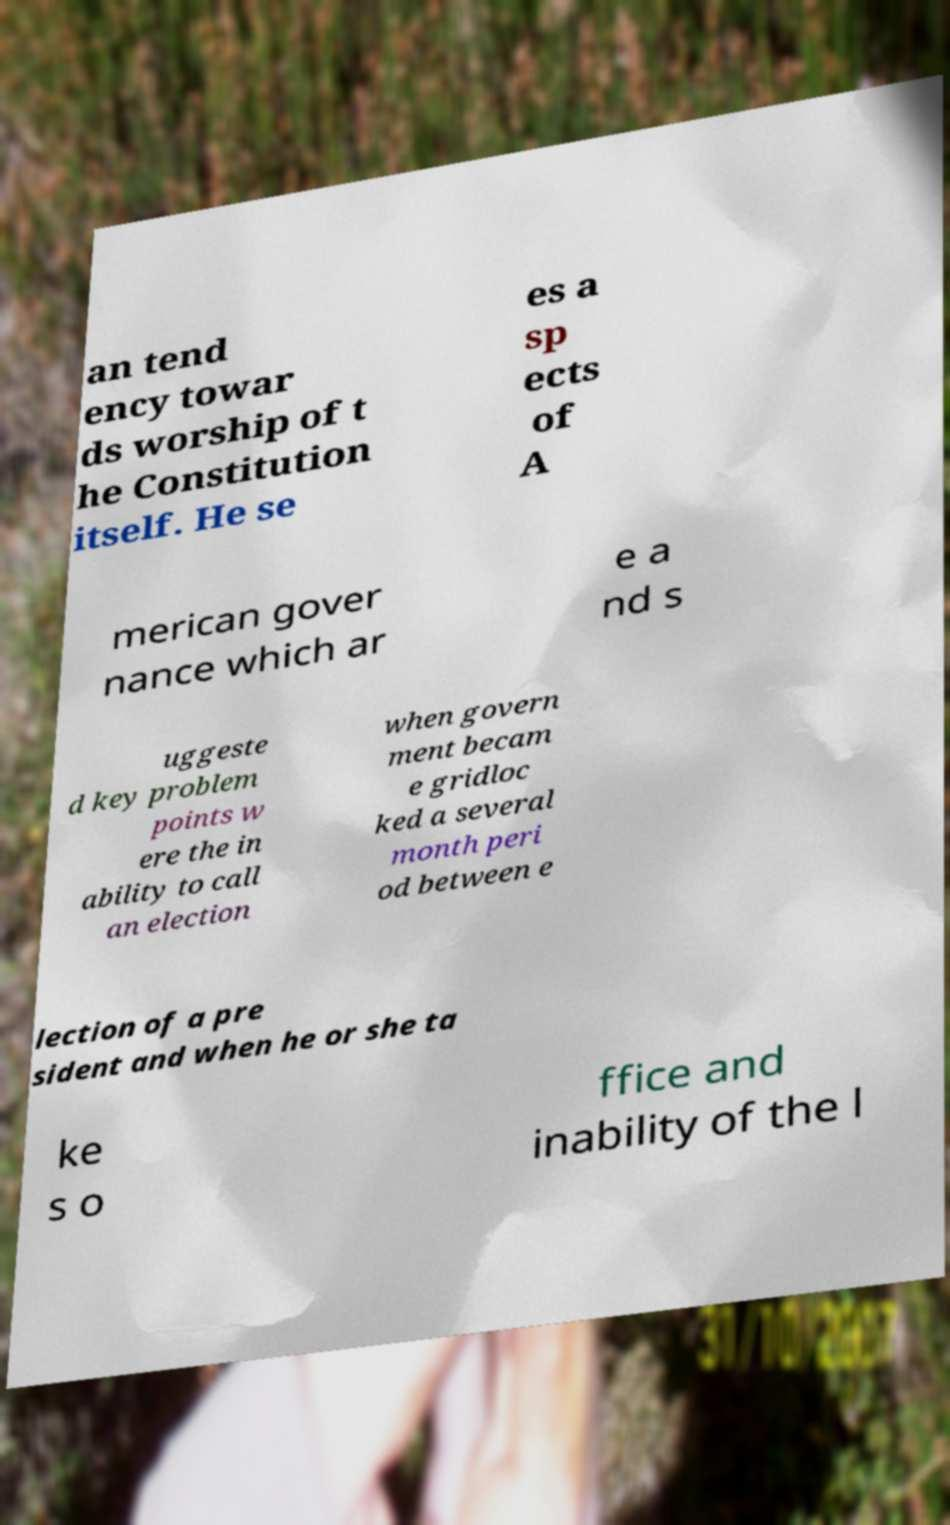Please identify and transcribe the text found in this image. an tend ency towar ds worship of t he Constitution itself. He se es a sp ects of A merican gover nance which ar e a nd s uggeste d key problem points w ere the in ability to call an election when govern ment becam e gridloc ked a several month peri od between e lection of a pre sident and when he or she ta ke s o ffice and inability of the l 